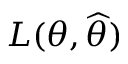Convert formula to latex. <formula><loc_0><loc_0><loc_500><loc_500>L ( \theta , { \widehat { \theta } } )</formula> 